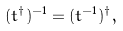Convert formula to latex. <formula><loc_0><loc_0><loc_500><loc_500>( t ^ { \dagger } ) ^ { - 1 } = ( t ^ { - 1 } ) ^ { \dagger } ,</formula> 